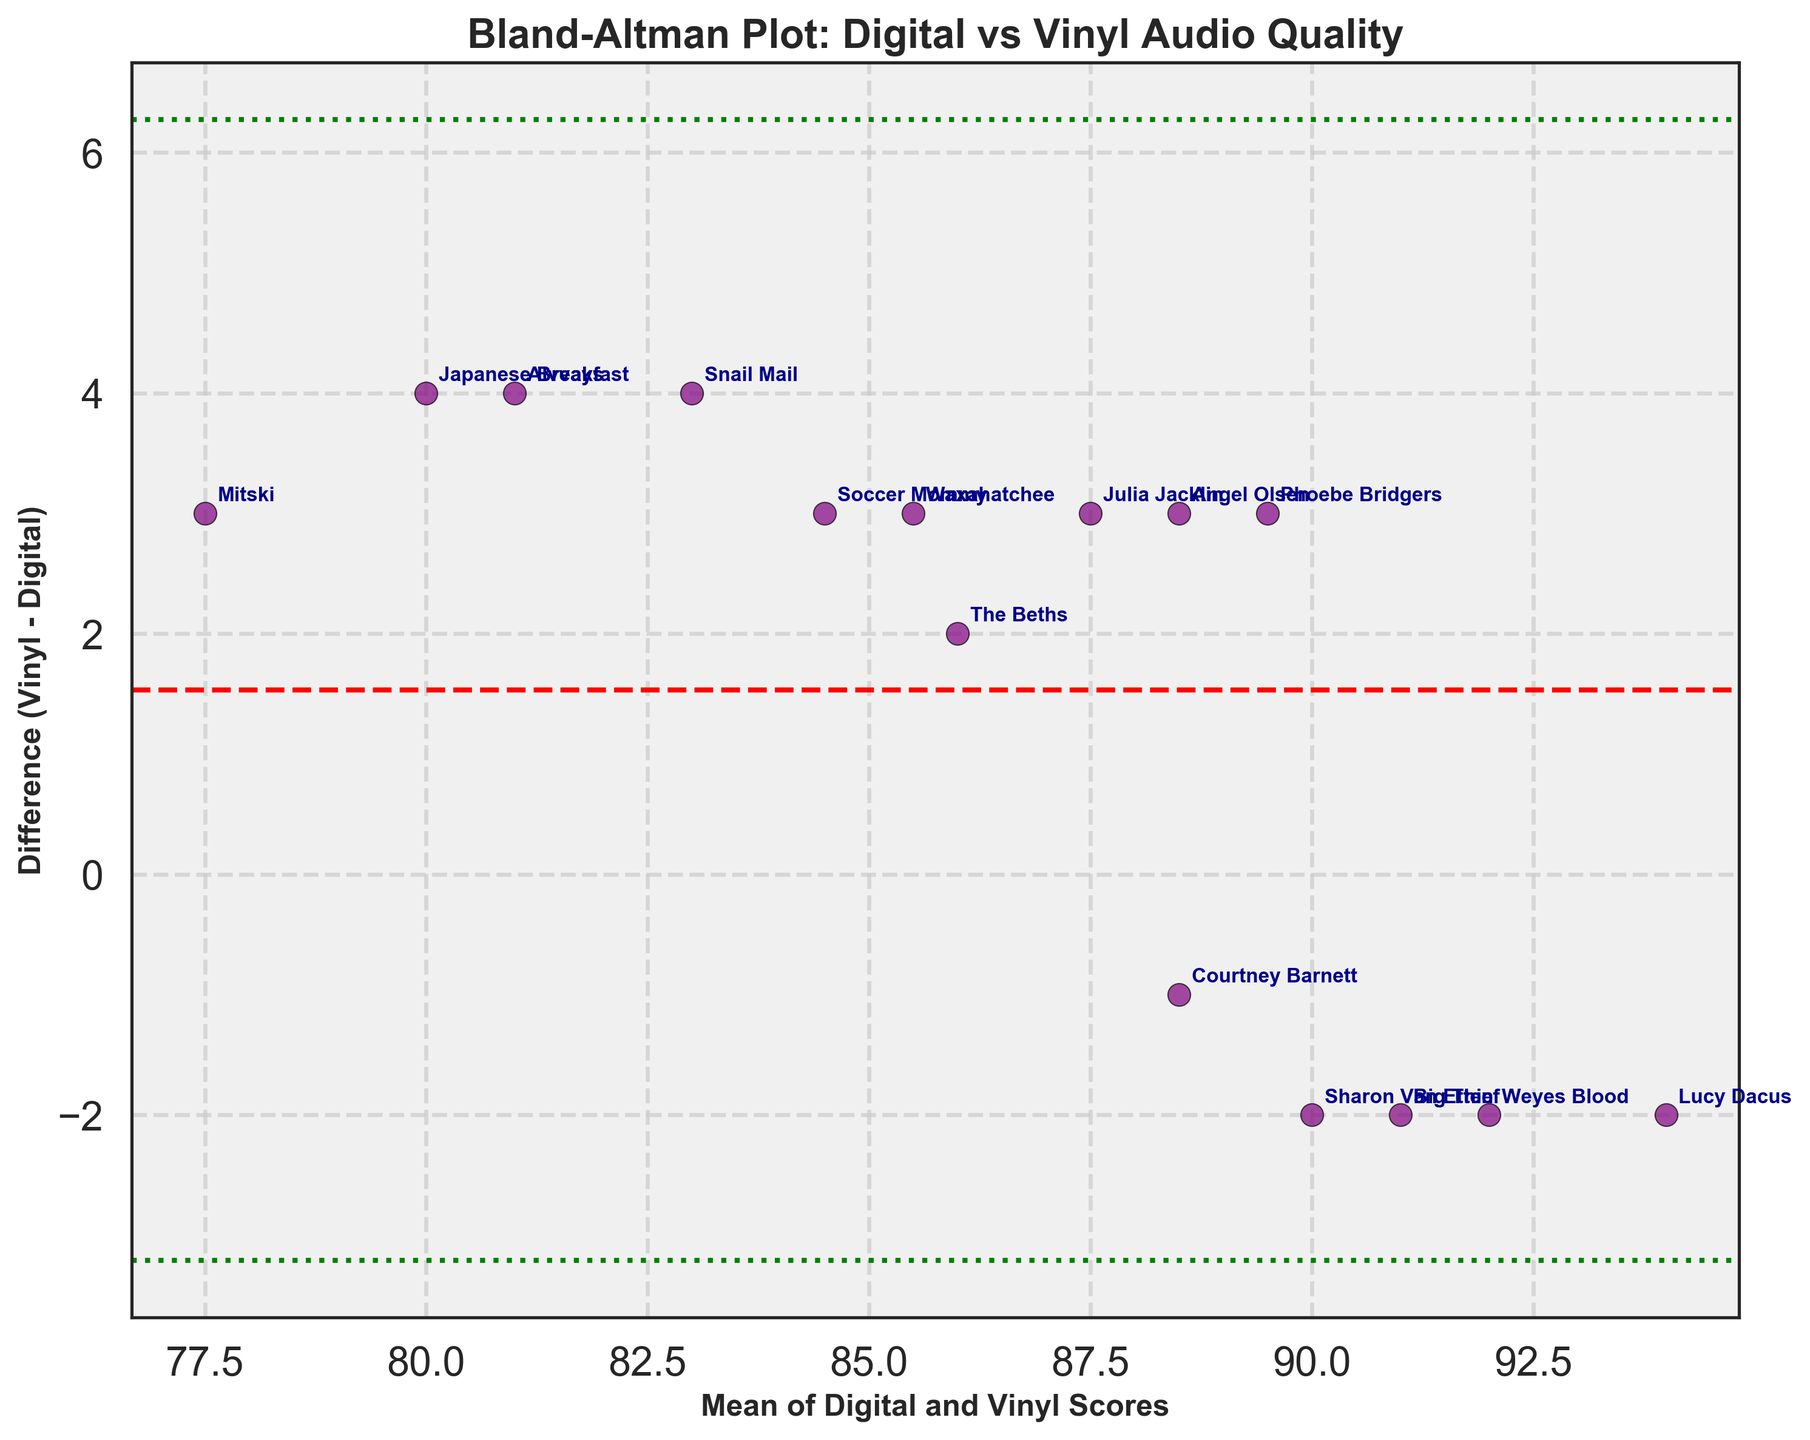How many data points are present in the plot? Each point in the plot represents a pair of audio quality scores from digital and vinyl formats. By counting these pairs, you can see there are 15 points.
Answer: 15 What is the title of the plot? The title of the plot is prominently displayed at the top in bold, indicating the main focus of the figure.
Answer: Bland-Altman Plot: Digital vs Vinyl Audio Quality Which artist shows the largest positive difference in audio quality score between vinyl and digital? By examining the scatter plot, we can identify the point with the highest positive y-value (difference). The annotated artist closest to this point is "Soccer Mommy".
Answer: Soccer Mommy What is the mean difference between audio quality scores on vinyl and digital formats? The mean difference is represented by the red dashed line across the plot.
Answer: Approximately 2.0 Which artist has the closest mean score between digital and vinyl formats? To find the artist with the closest audio quality scores, locate the data points closest to the x-axis (where the difference is nearly zero). The artist "Courtney Barnett" has a difference of approximately -1.
Answer: Courtney Barnett What is the color of the scatter points and edge colors used in the plot? The scatter points have a purple color with black edges, which is indicated by the colors used in the plot for readability.
Answer: Purple with black edges What do the two green dotted lines signify in the plot? These lines represent the 95% limits of agreement, calculated as the mean difference ± 1.96 times the standard deviation of the differences.
Answer: Limits of agreement Which artist has the highest combined mean audio quality score between digital and vinyl? By looking at the x-axis (mean of scores), the highest mean value can be identified. "Lucy Dacus" has the highest mean score.
Answer: Lucy Dacus What is the mean score difference for "Alvvays"? The difference for "Alvvays" can be found by locating the annotated point for Alvvays, which is about 4 units above the red dashed line.
Answer: 4 